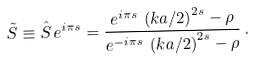Convert formula to latex. <formula><loc_0><loc_0><loc_500><loc_500>\tilde { S } \equiv \hat { S } \, e ^ { i \pi s } = \frac { e ^ { i \pi s } \, \left ( k a / 2 \right ) ^ { 2 s } - \rho } { e ^ { - i \pi s } \, \left ( k a / 2 \right ) ^ { 2 s } - \rho } \, .</formula> 